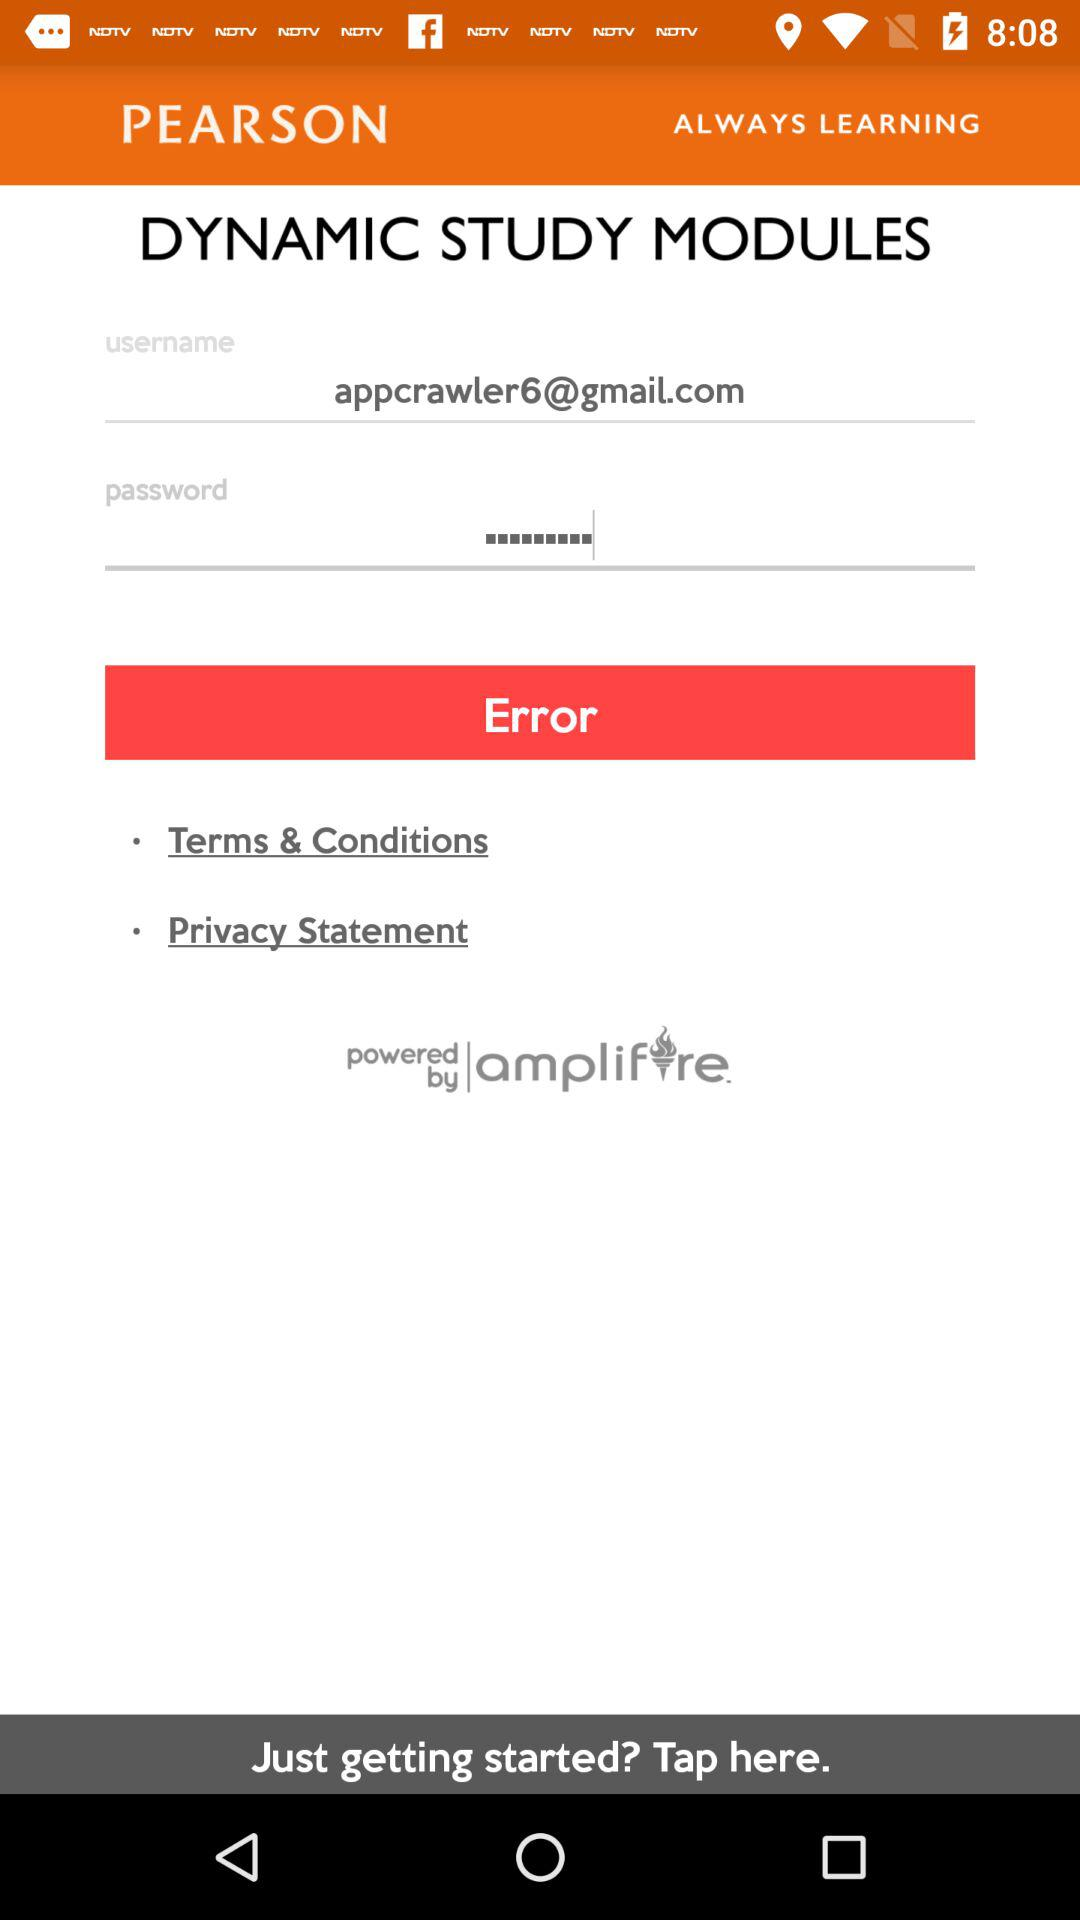What is the given email address? The given email address is appcrawler6@gmail.com. 